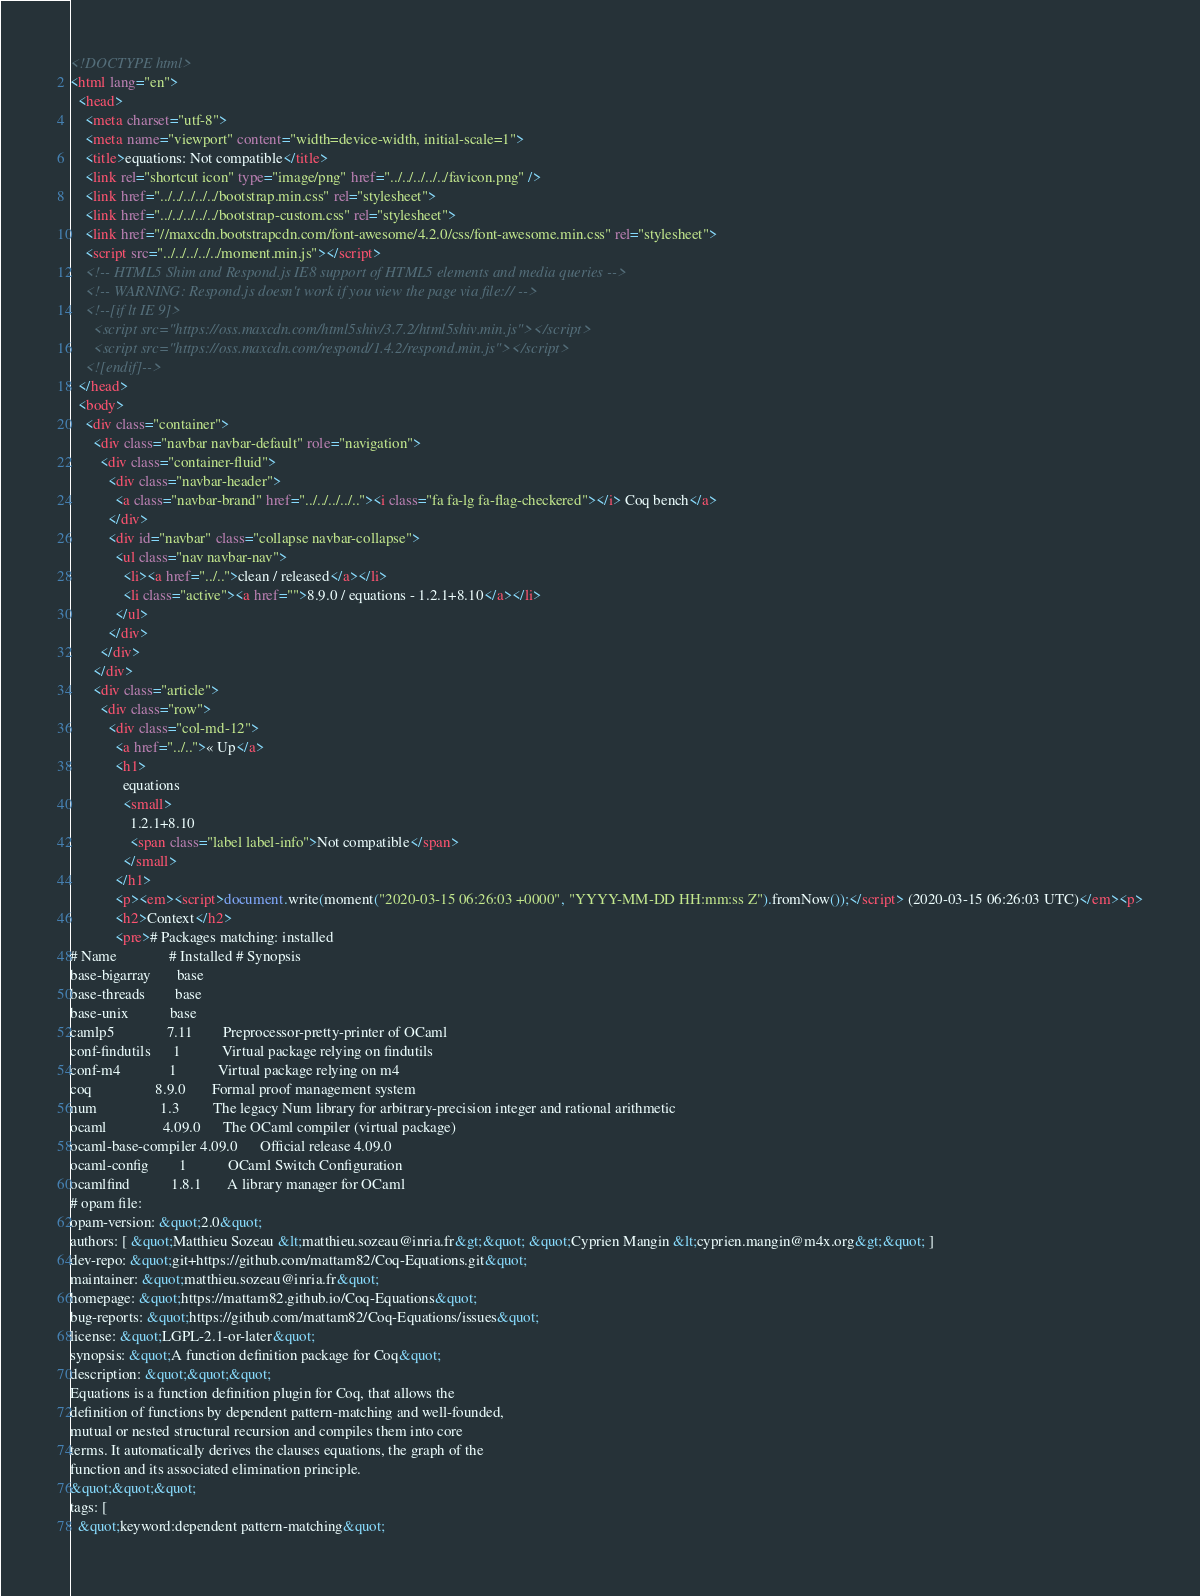<code> <loc_0><loc_0><loc_500><loc_500><_HTML_><!DOCTYPE html>
<html lang="en">
  <head>
    <meta charset="utf-8">
    <meta name="viewport" content="width=device-width, initial-scale=1">
    <title>equations: Not compatible</title>
    <link rel="shortcut icon" type="image/png" href="../../../../../favicon.png" />
    <link href="../../../../../bootstrap.min.css" rel="stylesheet">
    <link href="../../../../../bootstrap-custom.css" rel="stylesheet">
    <link href="//maxcdn.bootstrapcdn.com/font-awesome/4.2.0/css/font-awesome.min.css" rel="stylesheet">
    <script src="../../../../../moment.min.js"></script>
    <!-- HTML5 Shim and Respond.js IE8 support of HTML5 elements and media queries -->
    <!-- WARNING: Respond.js doesn't work if you view the page via file:// -->
    <!--[if lt IE 9]>
      <script src="https://oss.maxcdn.com/html5shiv/3.7.2/html5shiv.min.js"></script>
      <script src="https://oss.maxcdn.com/respond/1.4.2/respond.min.js"></script>
    <![endif]-->
  </head>
  <body>
    <div class="container">
      <div class="navbar navbar-default" role="navigation">
        <div class="container-fluid">
          <div class="navbar-header">
            <a class="navbar-brand" href="../../../../.."><i class="fa fa-lg fa-flag-checkered"></i> Coq bench</a>
          </div>
          <div id="navbar" class="collapse navbar-collapse">
            <ul class="nav navbar-nav">
              <li><a href="../..">clean / released</a></li>
              <li class="active"><a href="">8.9.0 / equations - 1.2.1+8.10</a></li>
            </ul>
          </div>
        </div>
      </div>
      <div class="article">
        <div class="row">
          <div class="col-md-12">
            <a href="../..">« Up</a>
            <h1>
              equations
              <small>
                1.2.1+8.10
                <span class="label label-info">Not compatible</span>
              </small>
            </h1>
            <p><em><script>document.write(moment("2020-03-15 06:26:03 +0000", "YYYY-MM-DD HH:mm:ss Z").fromNow());</script> (2020-03-15 06:26:03 UTC)</em><p>
            <h2>Context</h2>
            <pre># Packages matching: installed
# Name              # Installed # Synopsis
base-bigarray       base
base-threads        base
base-unix           base
camlp5              7.11        Preprocessor-pretty-printer of OCaml
conf-findutils      1           Virtual package relying on findutils
conf-m4             1           Virtual package relying on m4
coq                 8.9.0       Formal proof management system
num                 1.3         The legacy Num library for arbitrary-precision integer and rational arithmetic
ocaml               4.09.0      The OCaml compiler (virtual package)
ocaml-base-compiler 4.09.0      Official release 4.09.0
ocaml-config        1           OCaml Switch Configuration
ocamlfind           1.8.1       A library manager for OCaml
# opam file:
opam-version: &quot;2.0&quot;
authors: [ &quot;Matthieu Sozeau &lt;matthieu.sozeau@inria.fr&gt;&quot; &quot;Cyprien Mangin &lt;cyprien.mangin@m4x.org&gt;&quot; ]
dev-repo: &quot;git+https://github.com/mattam82/Coq-Equations.git&quot;
maintainer: &quot;matthieu.sozeau@inria.fr&quot;
homepage: &quot;https://mattam82.github.io/Coq-Equations&quot;
bug-reports: &quot;https://github.com/mattam82/Coq-Equations/issues&quot;
license: &quot;LGPL-2.1-or-later&quot;
synopsis: &quot;A function definition package for Coq&quot;
description: &quot;&quot;&quot;
Equations is a function definition plugin for Coq, that allows the
definition of functions by dependent pattern-matching and well-founded,
mutual or nested structural recursion and compiles them into core
terms. It automatically derives the clauses equations, the graph of the
function and its associated elimination principle.
&quot;&quot;&quot;
tags: [
  &quot;keyword:dependent pattern-matching&quot;</code> 